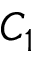<formula> <loc_0><loc_0><loc_500><loc_500>C _ { 1 }</formula> 